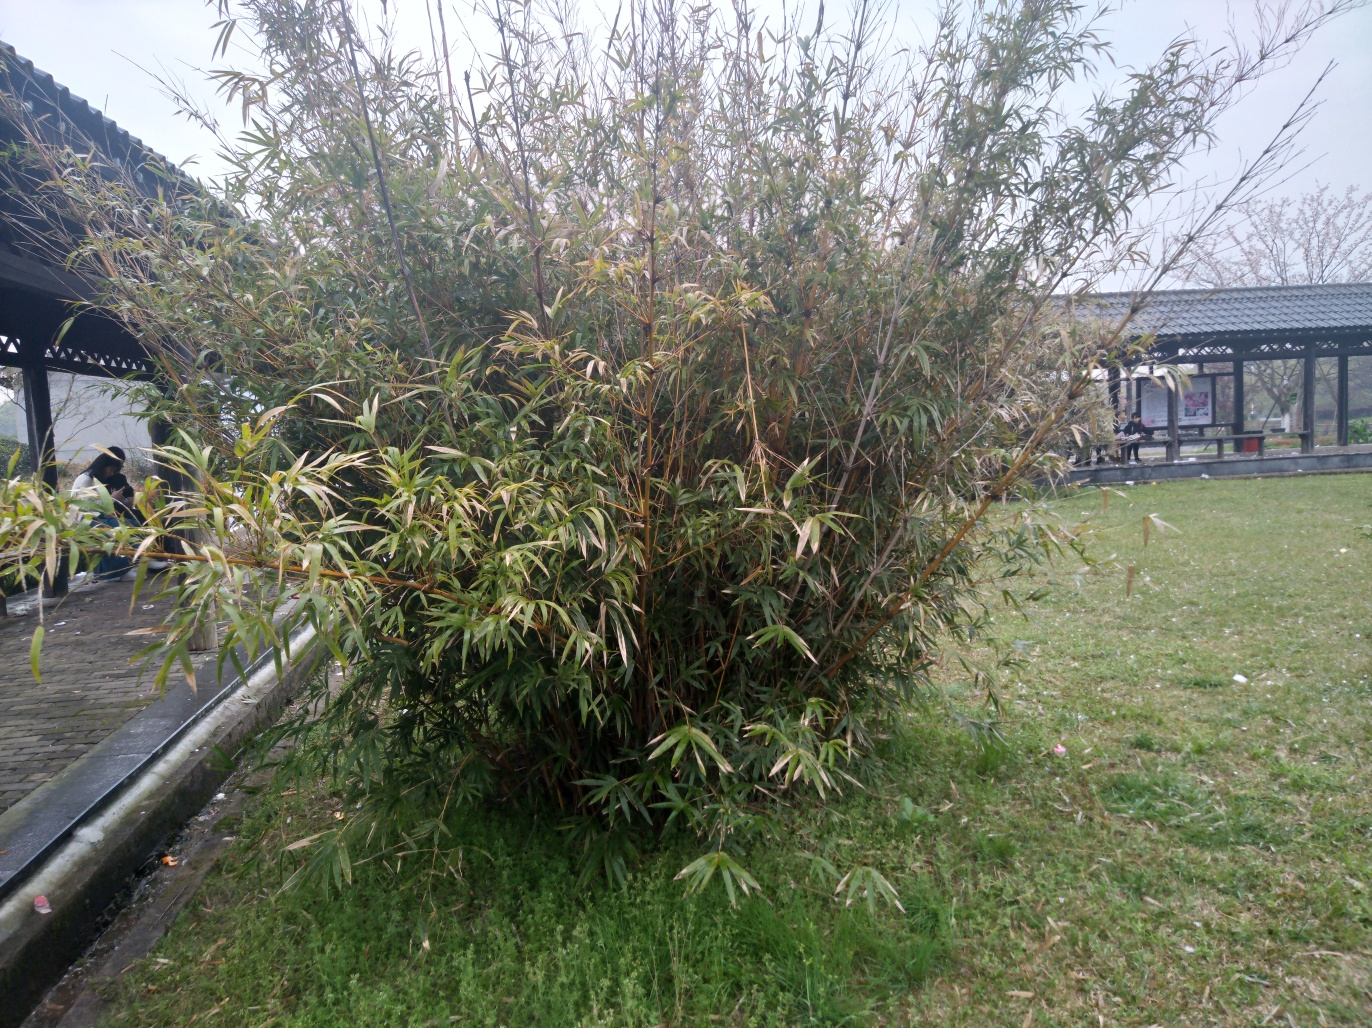Is there any loss of detail? Based on the visual content, the answer to whether there is any loss of detail is 'A. No'. The image appears clear and the details of the plants, grass, and structures in the background, such as the gazebo, are visible. The colors are distinct and the different shades of green, brown, and grey can be discerned. 